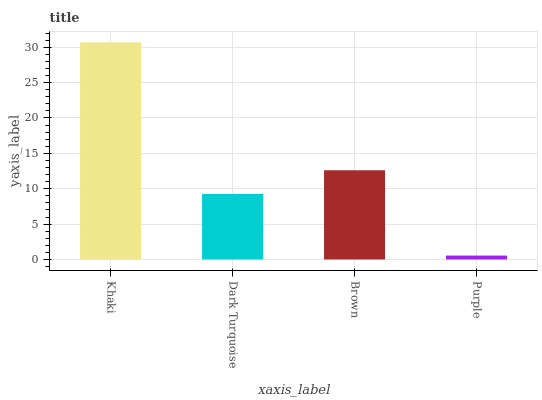Is Dark Turquoise the minimum?
Answer yes or no. No. Is Dark Turquoise the maximum?
Answer yes or no. No. Is Khaki greater than Dark Turquoise?
Answer yes or no. Yes. Is Dark Turquoise less than Khaki?
Answer yes or no. Yes. Is Dark Turquoise greater than Khaki?
Answer yes or no. No. Is Khaki less than Dark Turquoise?
Answer yes or no. No. Is Brown the high median?
Answer yes or no. Yes. Is Dark Turquoise the low median?
Answer yes or no. Yes. Is Purple the high median?
Answer yes or no. No. Is Khaki the low median?
Answer yes or no. No. 